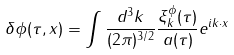<formula> <loc_0><loc_0><loc_500><loc_500>\delta \phi ( \tau , { x } ) = \int \frac { d ^ { 3 } k } { ( 2 \pi ) ^ { 3 / 2 } } \frac { \xi _ { k } ^ { \phi } ( \tau ) } { a ( \tau ) } e ^ { i { k } \cdot { x } }</formula> 